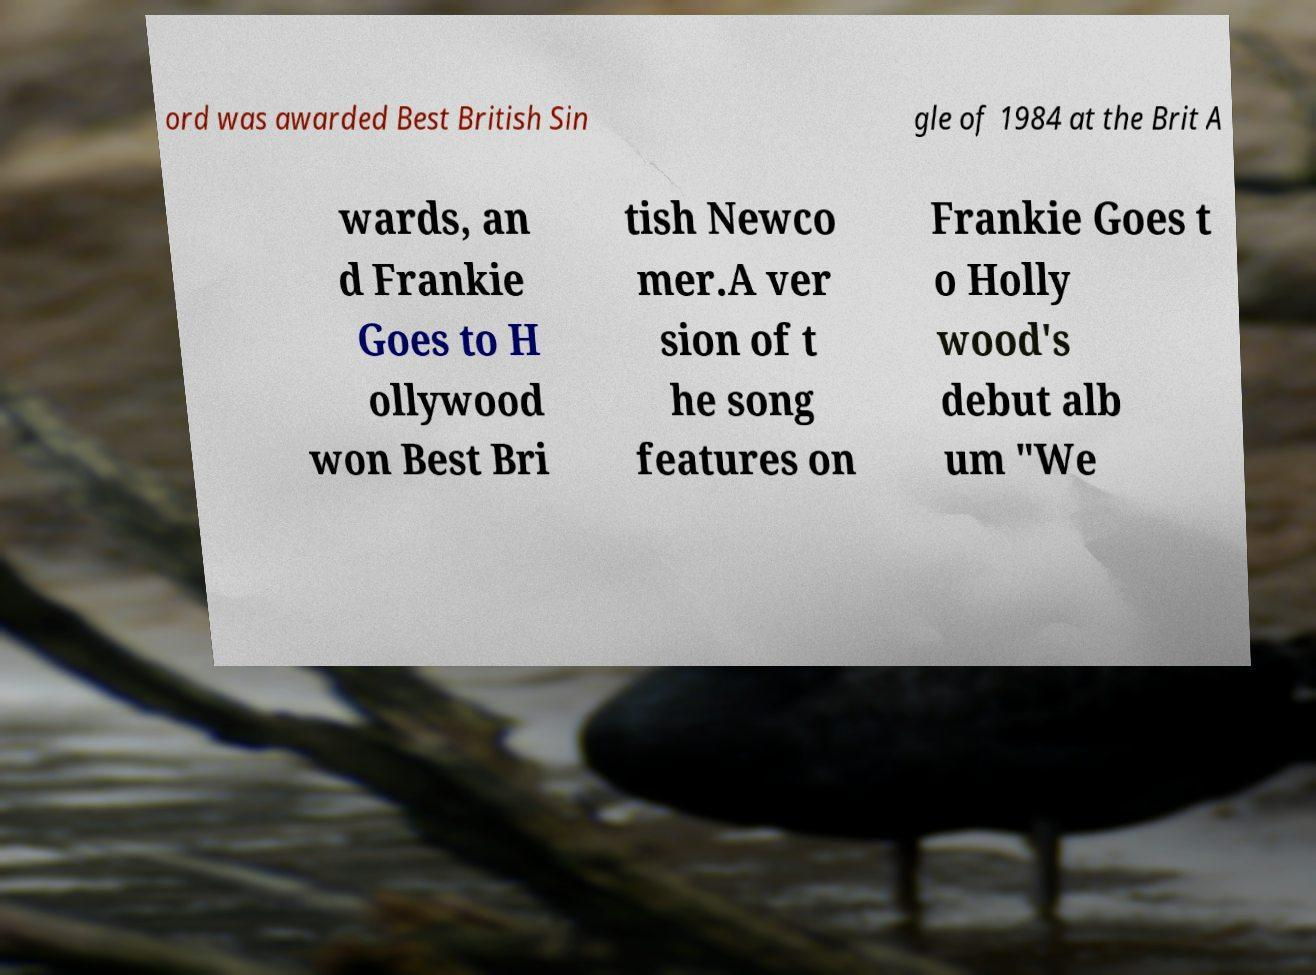Please read and relay the text visible in this image. What does it say? ord was awarded Best British Sin gle of 1984 at the Brit A wards, an d Frankie Goes to H ollywood won Best Bri tish Newco mer.A ver sion of t he song features on Frankie Goes t o Holly wood's debut alb um "We 